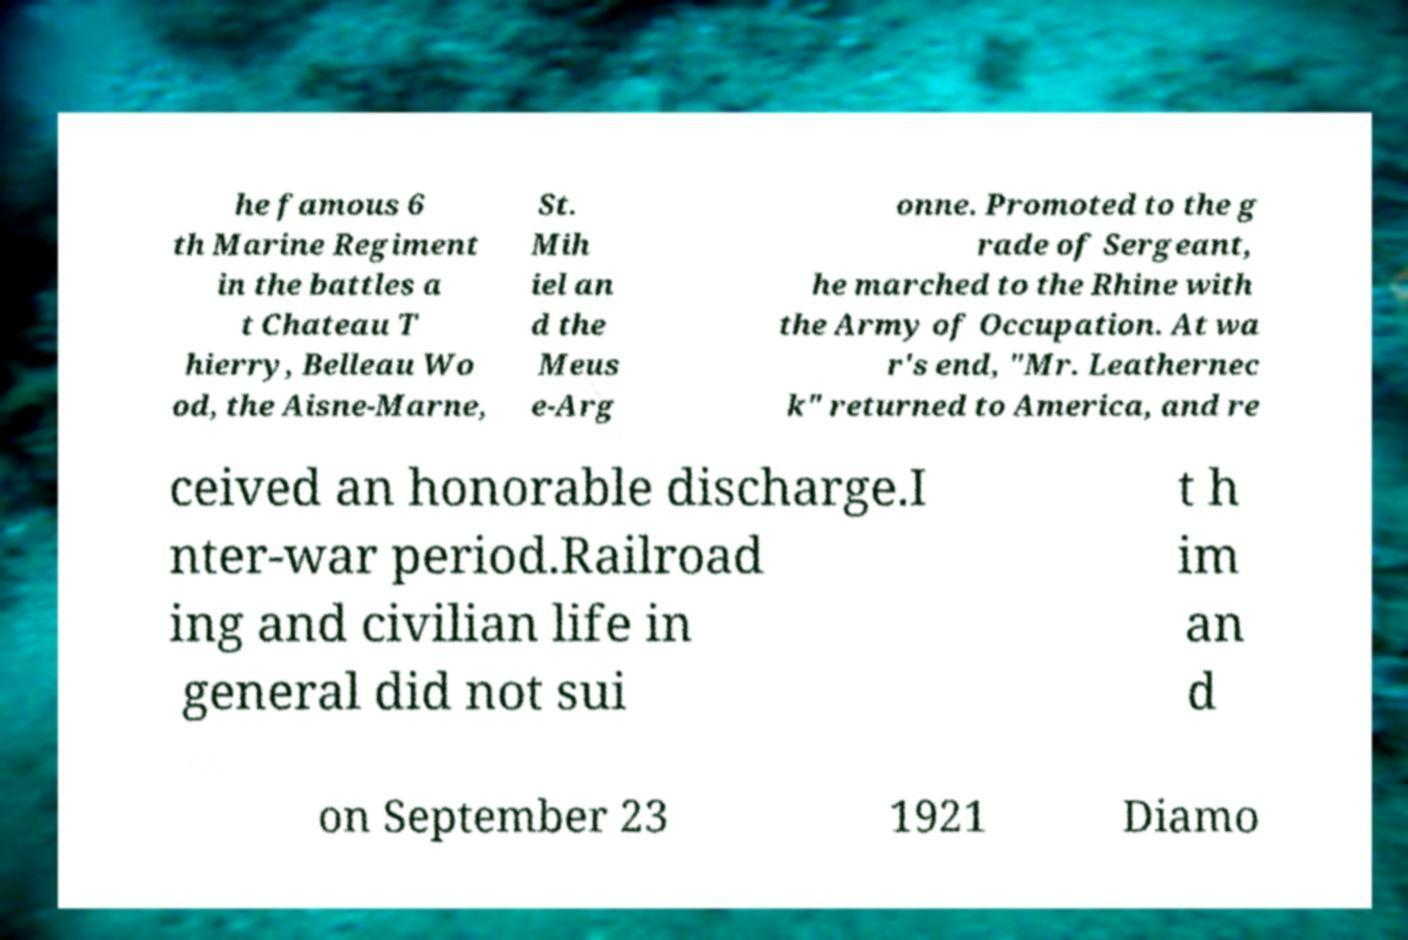What messages or text are displayed in this image? I need them in a readable, typed format. he famous 6 th Marine Regiment in the battles a t Chateau T hierry, Belleau Wo od, the Aisne-Marne, St. Mih iel an d the Meus e-Arg onne. Promoted to the g rade of Sergeant, he marched to the Rhine with the Army of Occupation. At wa r's end, "Mr. Leathernec k" returned to America, and re ceived an honorable discharge.I nter-war period.Railroad ing and civilian life in general did not sui t h im an d on September 23 1921 Diamo 